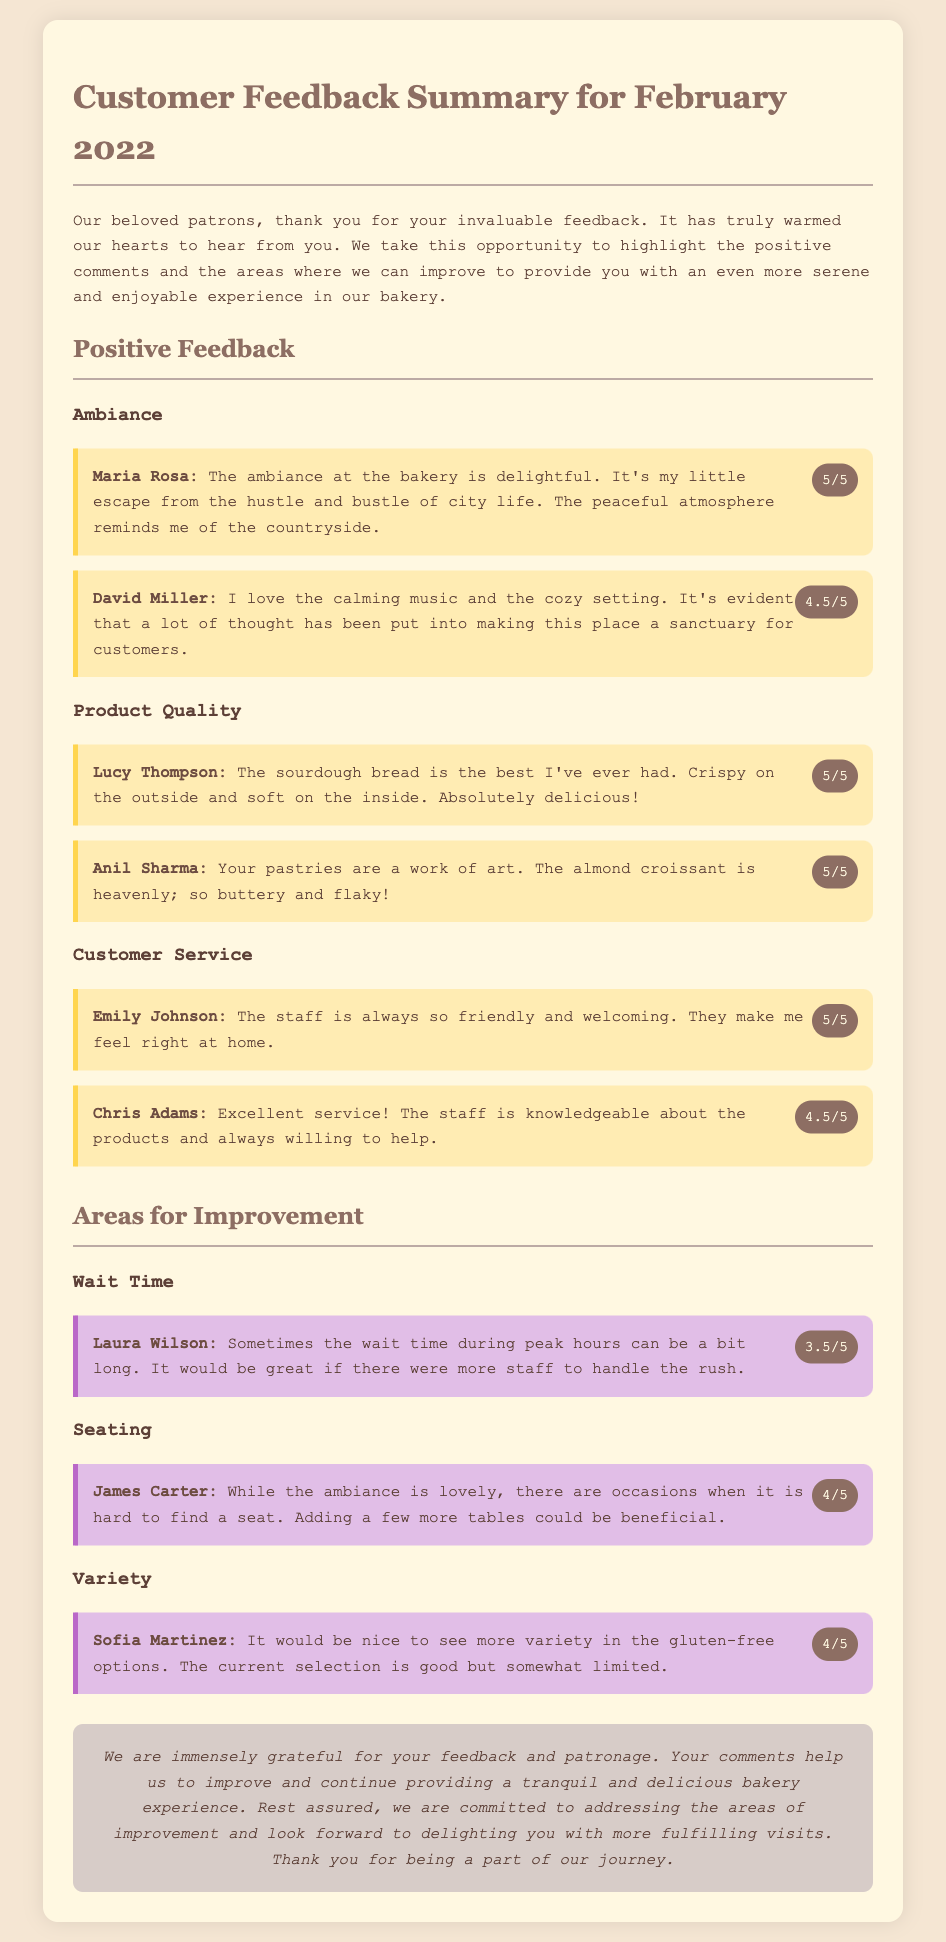What is the rating given by Maria Rosa? Maria Rosa's feedback indicates a rating of 5 out of 5 in the Ambiance section.
Answer: 5/5 Who mentioned the need for more gluten-free options? Sofia Martinez pointed out that the current selection of gluten-free options is somewhat limited.
Answer: Sofia Martinez What is the rating for wait time according to Laura Wilson? Laura Wilson provided a rating of 3.5 out of 5 for wait time.
Answer: 3.5/5 How many positive feedback items are mentioned in the Customer Service section? There are two items in the Customer Service section providing positive feedback.
Answer: 2 What aspect did James Carter suggest improving? James Carter mentioned that adding more tables could improve seating availability.
Answer: Seating What did Lucy Thompson think of the sourdough bread? Lucy Thompson described the sourdough bread as the best she has ever had.
Answer: Best ever Which month is this feedback summary for? The document specifically states the feedback summary is for February 2022.
Answer: February 2022 What color is used for the improvement items background? The background color for the improvement items is E1BEE7.
Answer: E1BEE7 What is the overall message in the conclusion? The conclusion expresses gratitude for feedback and a commitment to improvement.
Answer: Thank you for your feedback 